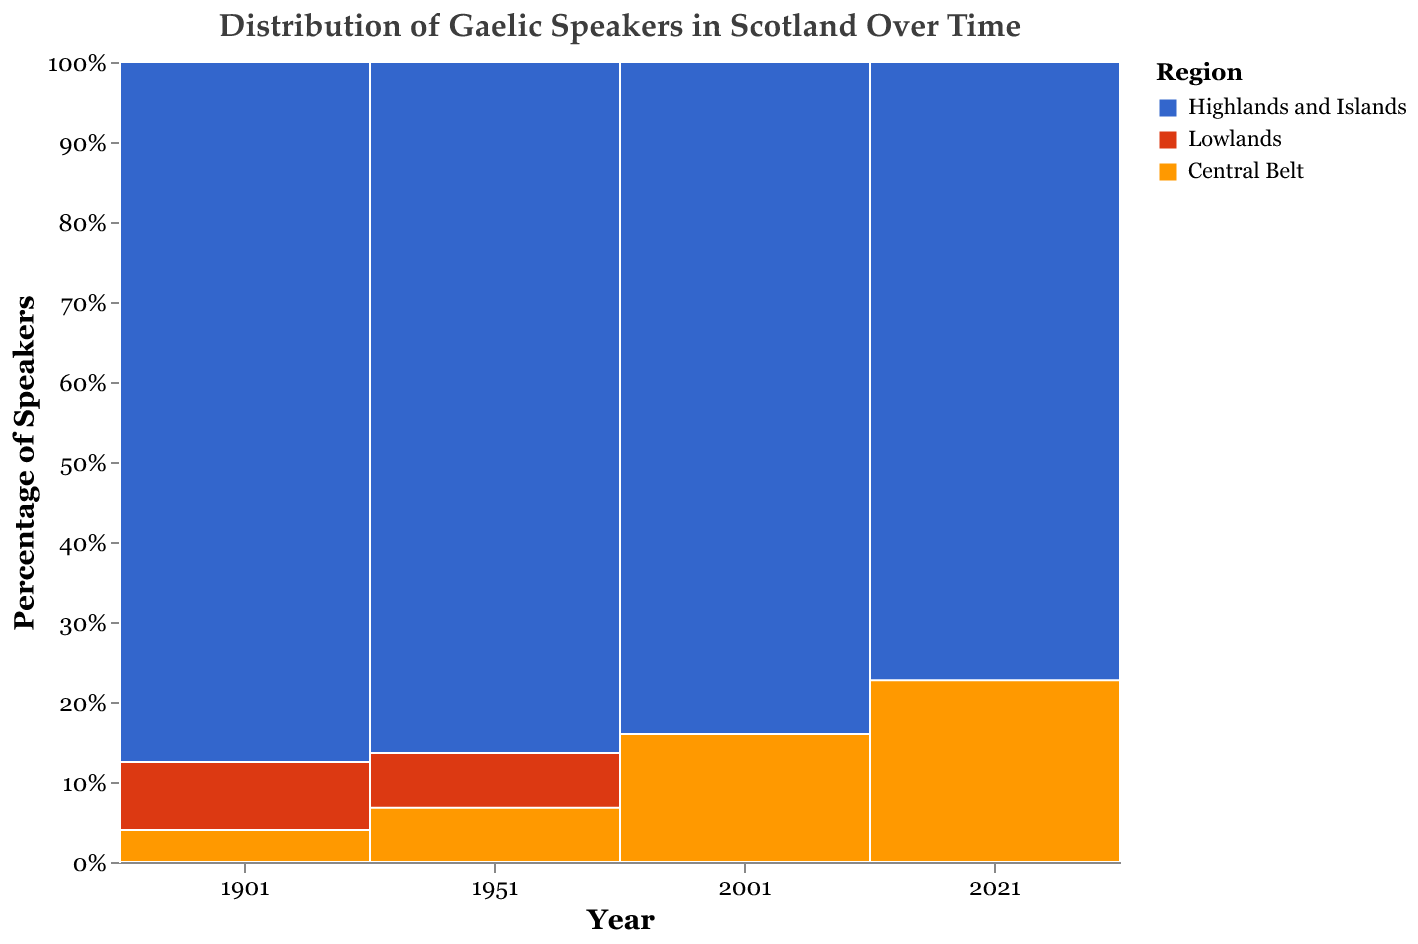What is the title of the figure? The title of the figure is located at the top and describes what the plot is about. The title reads "Distribution of Gaelic Speakers in Scotland Over Time".
Answer: Distribution of Gaelic Speakers in Scotland Over Time Which region had the highest percentage of Gaelic speakers in 1901? The section for the year 1901 is dominated by the color representing the Highlands and Islands.
Answer: Highlands and Islands How did the percentage of Gaelic speakers in the Central Belt change from 1901 to 2021? In 1901, the Central Belt had a small section compared to other regions, and it grew slightly by 2021. The color representing the Central Belt increases in height over time, indicating an increase in percentage.
Answer: Increased Which year saw the greatest decline in the percentage of Gaelic speakers in the Highlands and Islands? Comparing the height of the sections for the Highlands and Islands across years, the greatest decline occurs from 1901 to 1951.
Answer: 1951 What is the total percentage of Gaelic speakers in the Lowlands and Central Belt combined in 2021? The sections for the Lowlands and Central Belt in 2021 can be added together based on their heights. Lowlands contribute approximately 0.4%, and Central Belt contributes approximately 0.8%, adding up to 1.2%.
Answer: 1.2% In which year did the percentage of speakers in the Highlands and Islands fall below 50%? Comparing the heights of the sections representing the Highlands and Islands, the percentage drops below 50% for the first time in 1951.
Answer: 1951 Which regions had the lowest percentage of Gaelic speakers in 1951? The sections for the Lowlands and Central Belt are both very small in 1951, each contributing only a small fraction compared to the Highlands and Islands.
Answer: Lowlands and Central Belt Compare the trend in Gaelic speakers' percentages between the Central Belt and Lowlands from 1901 to 2021. The Lowlands show a slight decrease over time, while the Central Belt shows a slight increase, especially notable between 2001 and 2021.
Answer: Central Belt increased, Lowlands decreased What can be inferred about the distribution of Gaelic speakers across Scotland from 1901 to 2021? Over time, the percentage of Gaelic speakers in the Highlands and Islands decreased significantly, whereas the Central Belt showed a slight increase and the Lowlands remained fairly stable but low.
Answer: Decrease in Highlands and Islands, slight increase in Central Belt Which year had the most balanced distribution of Gaelic speakers among the three regions? The year with the most evenly tall sections for all regions would indicate a more balanced distribution. This occurs in year 2021, where the sections for the three regions are more similar in size compared to other years.
Answer: 2021 